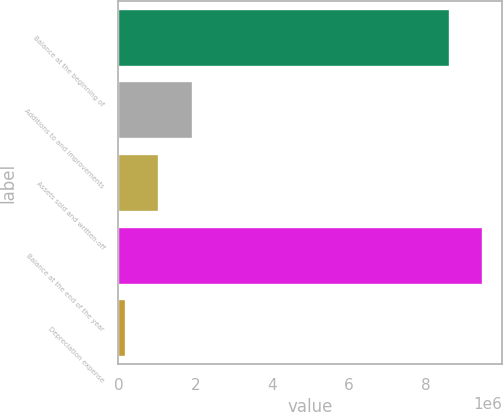<chart> <loc_0><loc_0><loc_500><loc_500><bar_chart><fcel>Balance at the beginning of<fcel>Additions to and improvements<fcel>Assets sold and written-off<fcel>Balance at the end of the year<fcel>Depreciation expense<nl><fcel>8.6207e+06<fcel>1.93307e+06<fcel>1.05998e+06<fcel>9.49379e+06<fcel>186886<nl></chart> 